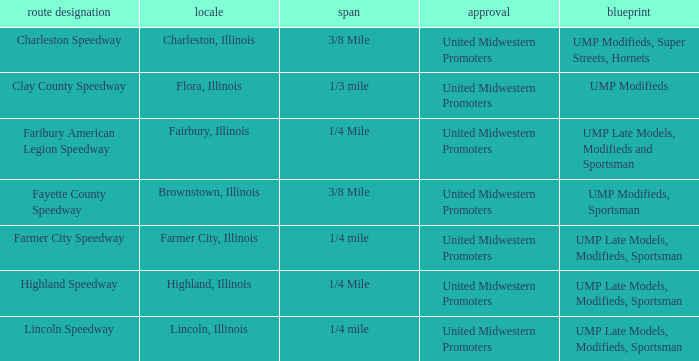What location is farmer city speedway? Farmer City, Illinois. 